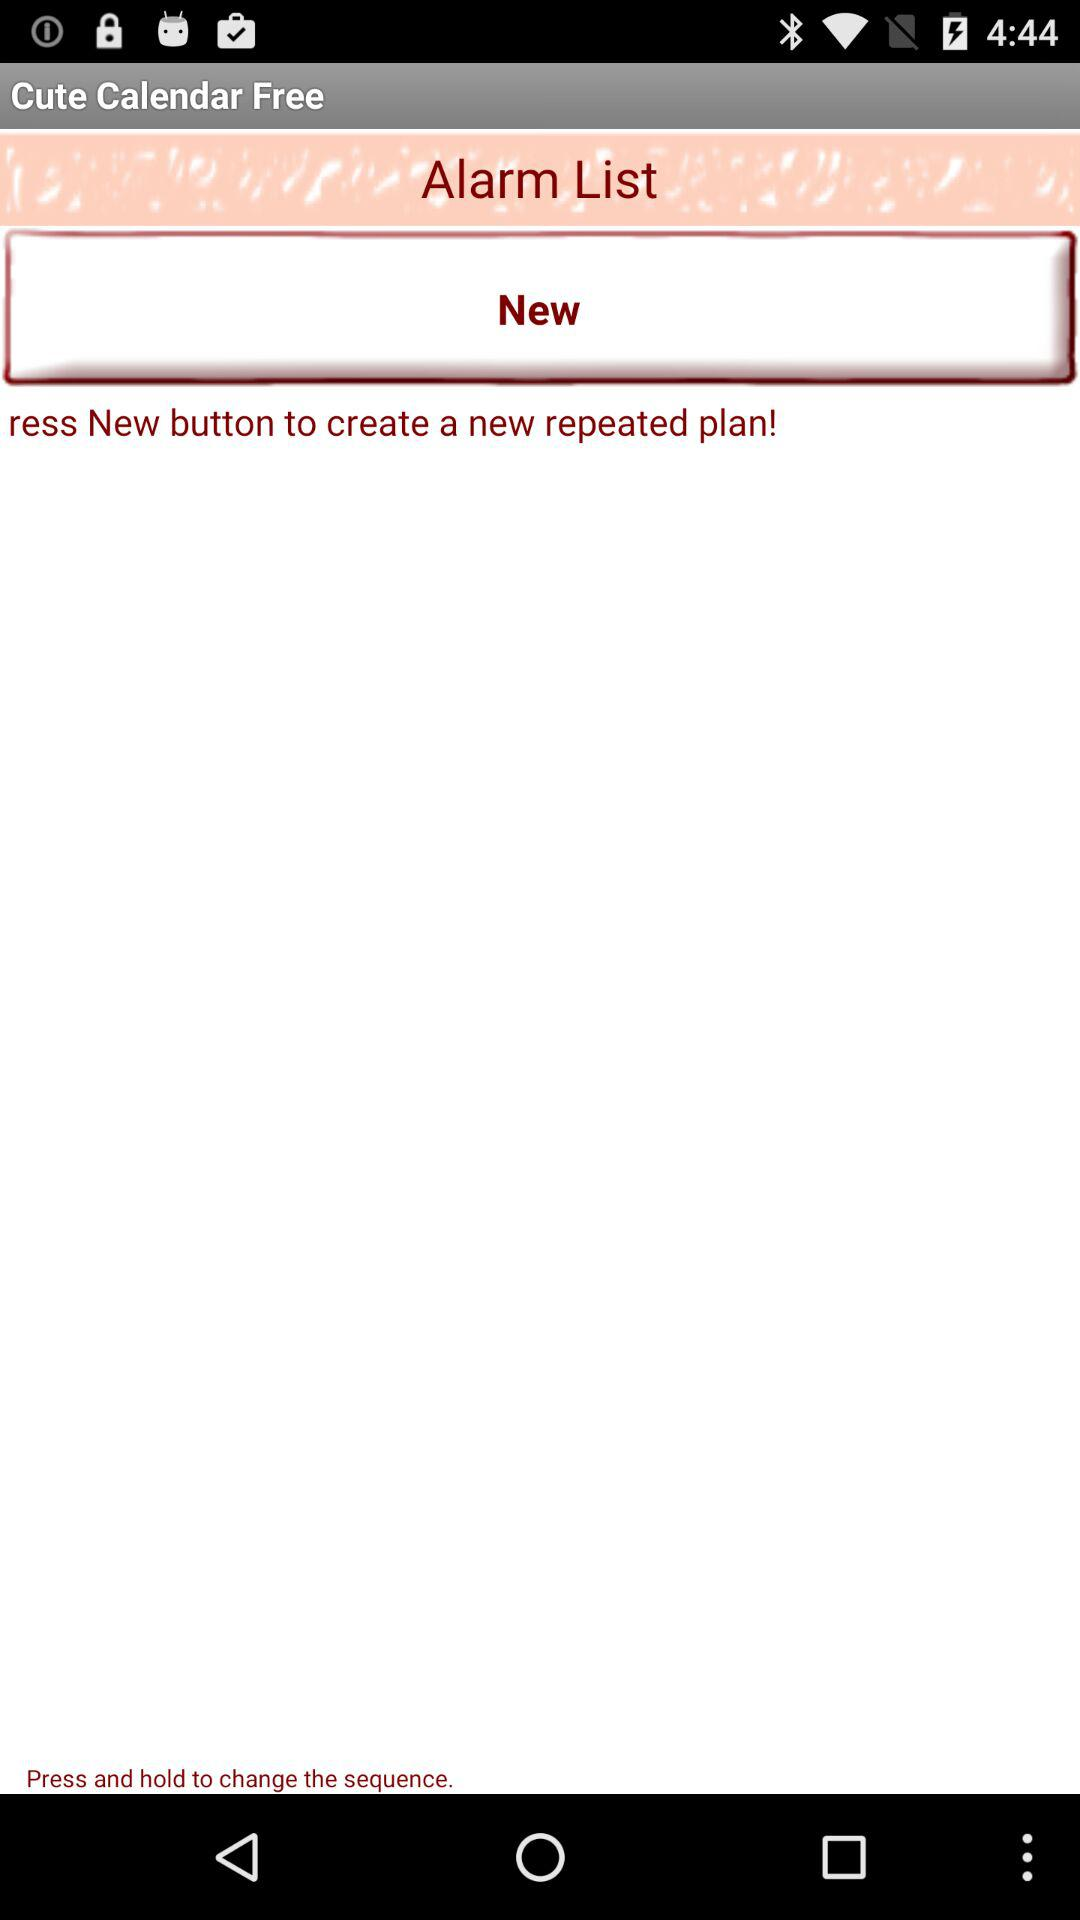Is there something specific about the design that indicates this application is targeted towards a certain user group? The soft pink color scheme and playful font style used in the 'Cute Calendar Free' suggest that the application might be targeted towards a younger audience or those who appreciate a more whimsical, visually engaging design over a traditional, business-like appearance. Does the time shown at the screen's top-right give us any relevant information about the app's usage? The time displayed at 4:44 could suggest that the screenshot was taken at a moment of non-active use, potentially overnight or during early hours when usage is less frequent. However, this timing doesn't necessarily provide direct insights into the specific uses of the app. 